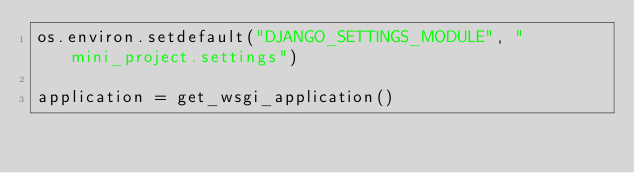<code> <loc_0><loc_0><loc_500><loc_500><_Python_>os.environ.setdefault("DJANGO_SETTINGS_MODULE", "mini_project.settings")

application = get_wsgi_application()
</code> 